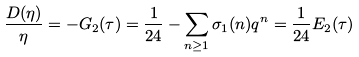Convert formula to latex. <formula><loc_0><loc_0><loc_500><loc_500>\frac { D ( \eta ) } { \eta } = - G _ { 2 } ( \tau ) = \frac { 1 } { 2 4 } - \sum _ { n \geq 1 } \sigma _ { 1 } ( n ) q ^ { n } = \frac { 1 } { 2 4 } E _ { 2 } ( \tau )</formula> 